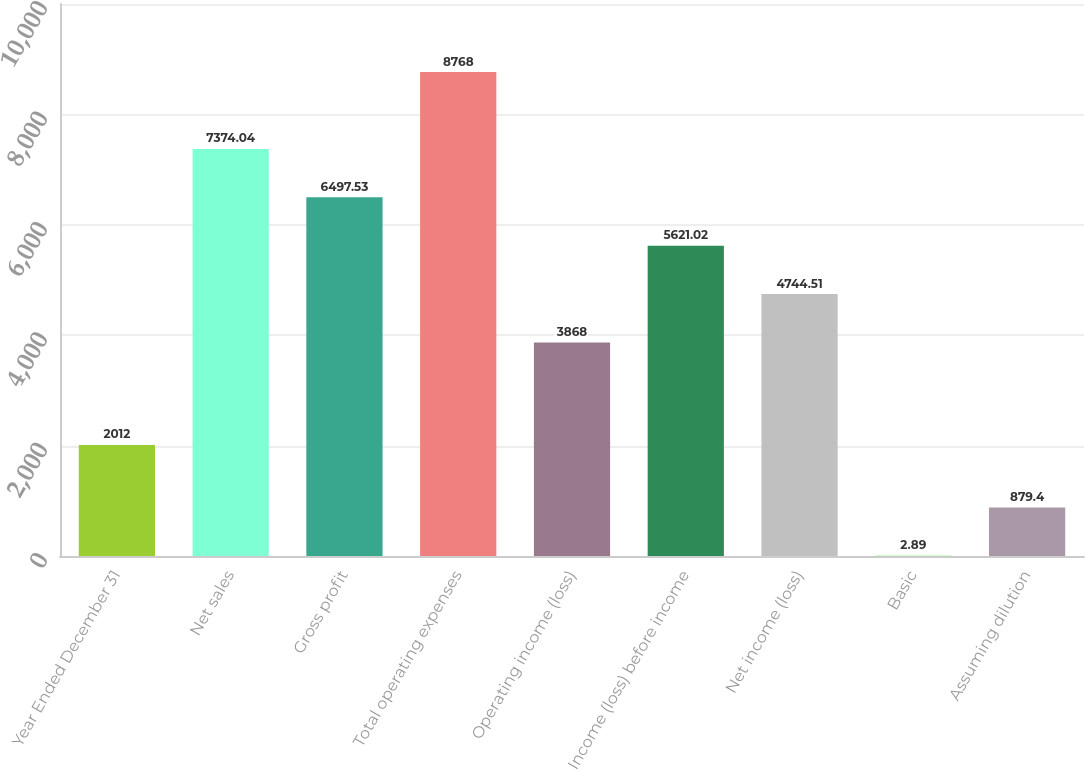<chart> <loc_0><loc_0><loc_500><loc_500><bar_chart><fcel>Year Ended December 31<fcel>Net sales<fcel>Gross profit<fcel>Total operating expenses<fcel>Operating income (loss)<fcel>Income (loss) before income<fcel>Net income (loss)<fcel>Basic<fcel>Assuming dilution<nl><fcel>2012<fcel>7374.04<fcel>6497.53<fcel>8768<fcel>3868<fcel>5621.02<fcel>4744.51<fcel>2.89<fcel>879.4<nl></chart> 